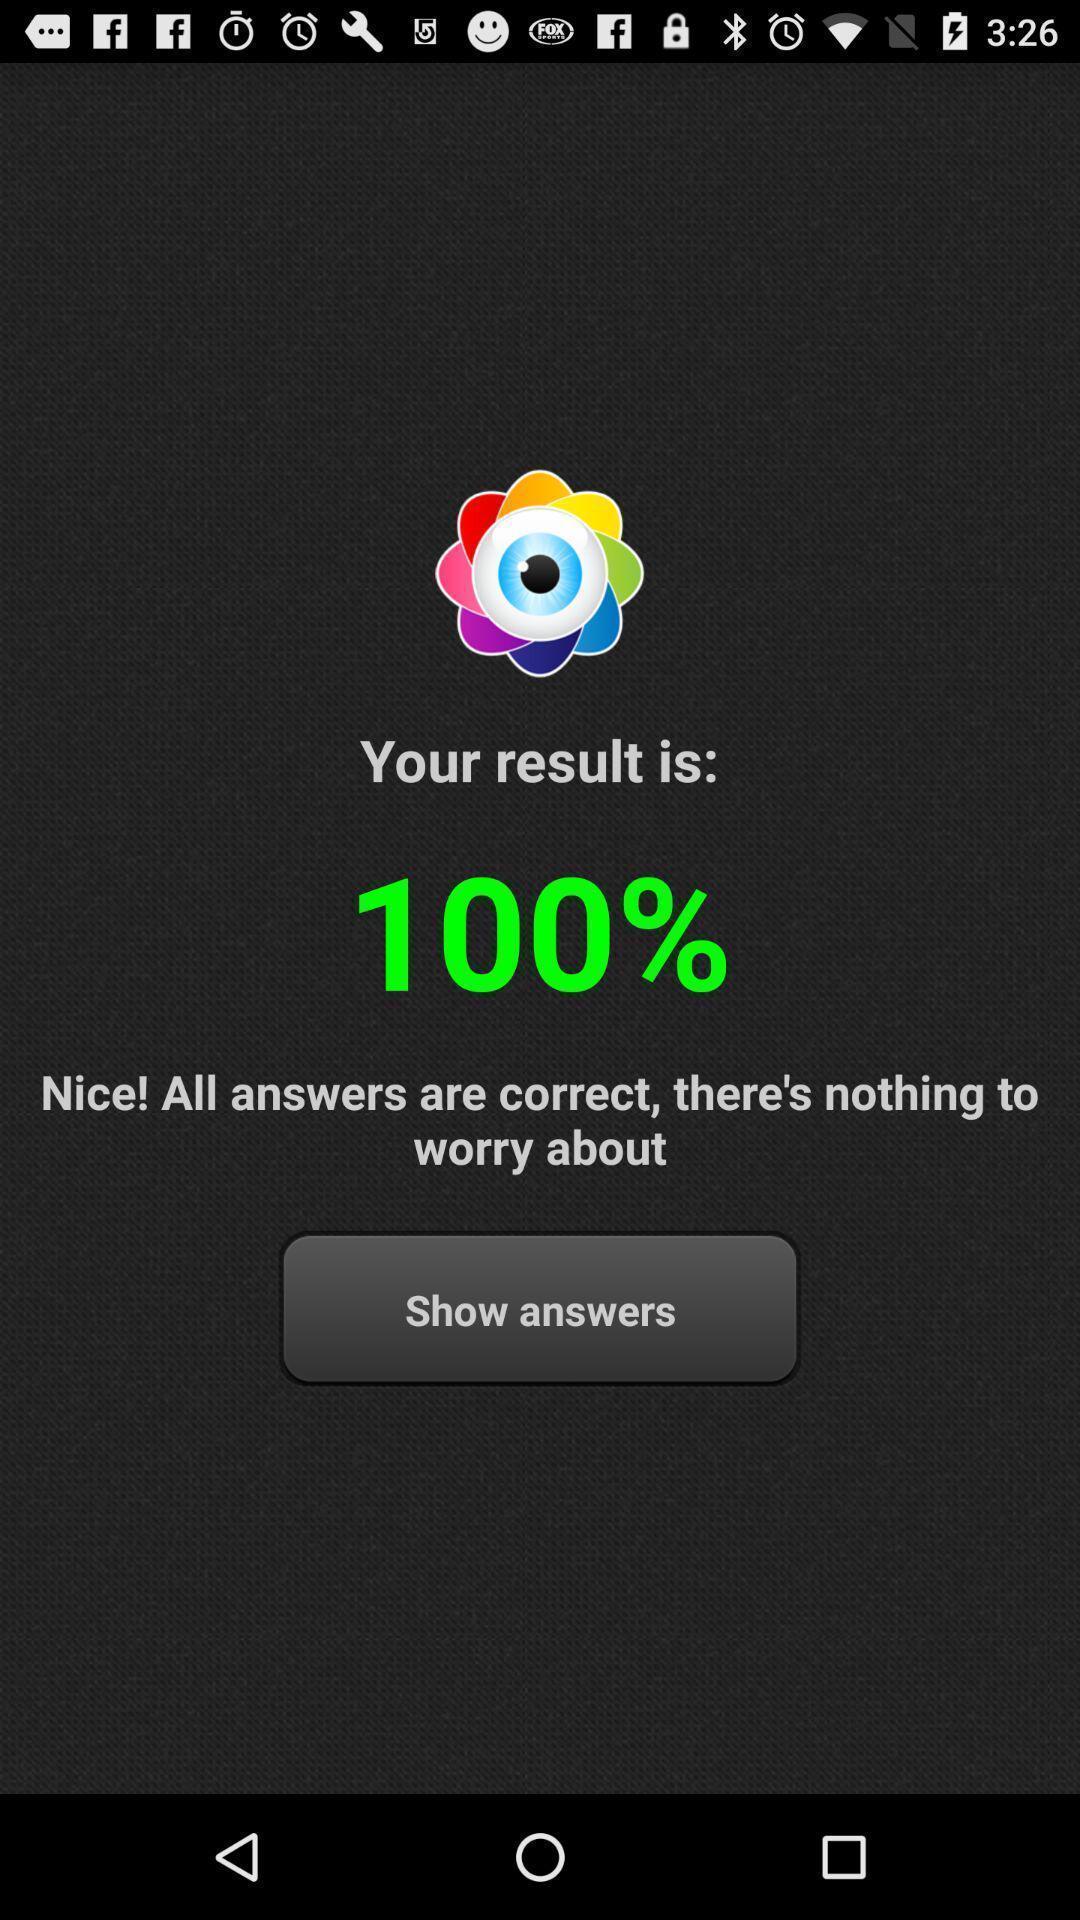What is the overall content of this screenshot? Screen shows results. 